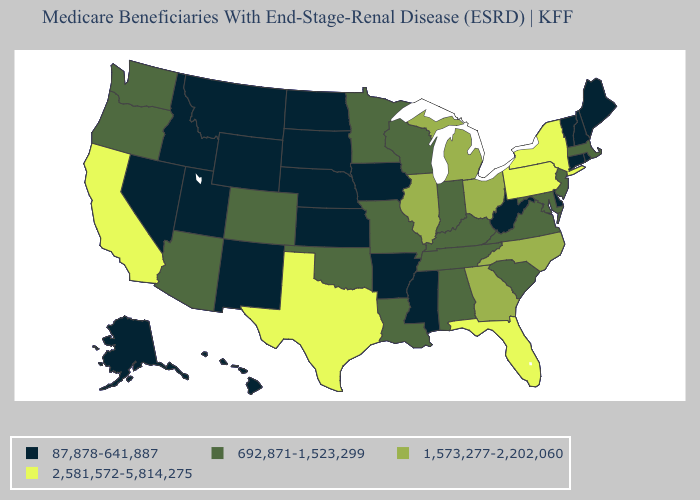What is the highest value in the USA?
Short answer required. 2,581,572-5,814,275. What is the lowest value in states that border Kansas?
Give a very brief answer. 87,878-641,887. What is the lowest value in the Northeast?
Be succinct. 87,878-641,887. Is the legend a continuous bar?
Write a very short answer. No. What is the value of Colorado?
Keep it brief. 692,871-1,523,299. Does Kentucky have a higher value than Alabama?
Write a very short answer. No. Among the states that border Pennsylvania , which have the lowest value?
Quick response, please. Delaware, West Virginia. Does Virginia have a lower value than Louisiana?
Keep it brief. No. What is the highest value in the USA?
Concise answer only. 2,581,572-5,814,275. Which states have the lowest value in the USA?
Write a very short answer. Alaska, Arkansas, Connecticut, Delaware, Hawaii, Idaho, Iowa, Kansas, Maine, Mississippi, Montana, Nebraska, Nevada, New Hampshire, New Mexico, North Dakota, Rhode Island, South Dakota, Utah, Vermont, West Virginia, Wyoming. Does New York have the highest value in the Northeast?
Keep it brief. Yes. Name the states that have a value in the range 1,573,277-2,202,060?
Keep it brief. Georgia, Illinois, Michigan, North Carolina, Ohio. Which states hav the highest value in the West?
Be succinct. California. Among the states that border New Jersey , does New York have the lowest value?
Concise answer only. No. Which states hav the highest value in the West?
Give a very brief answer. California. 